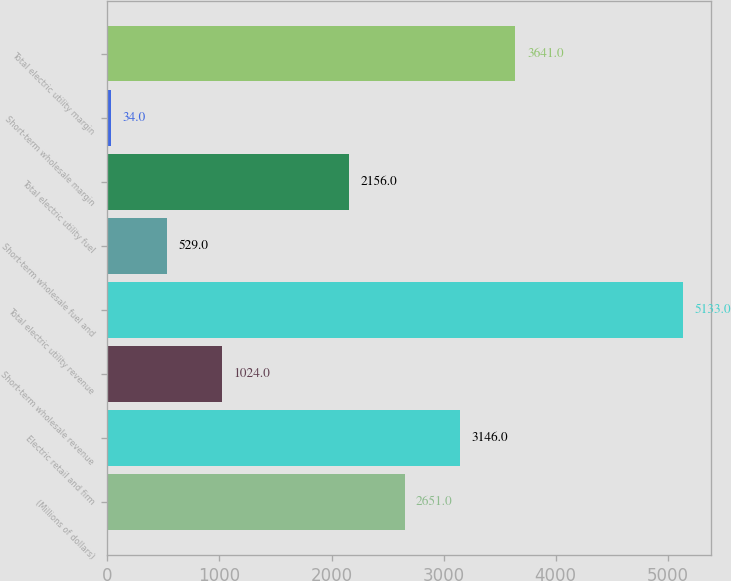<chart> <loc_0><loc_0><loc_500><loc_500><bar_chart><fcel>(Millions of dollars)<fcel>Electric retail and firm<fcel>Short-term wholesale revenue<fcel>Total electric utility revenue<fcel>Short-term wholesale fuel and<fcel>Total electric utility fuel<fcel>Short-term wholesale margin<fcel>Total electric utility margin<nl><fcel>2651<fcel>3146<fcel>1024<fcel>5133<fcel>529<fcel>2156<fcel>34<fcel>3641<nl></chart> 